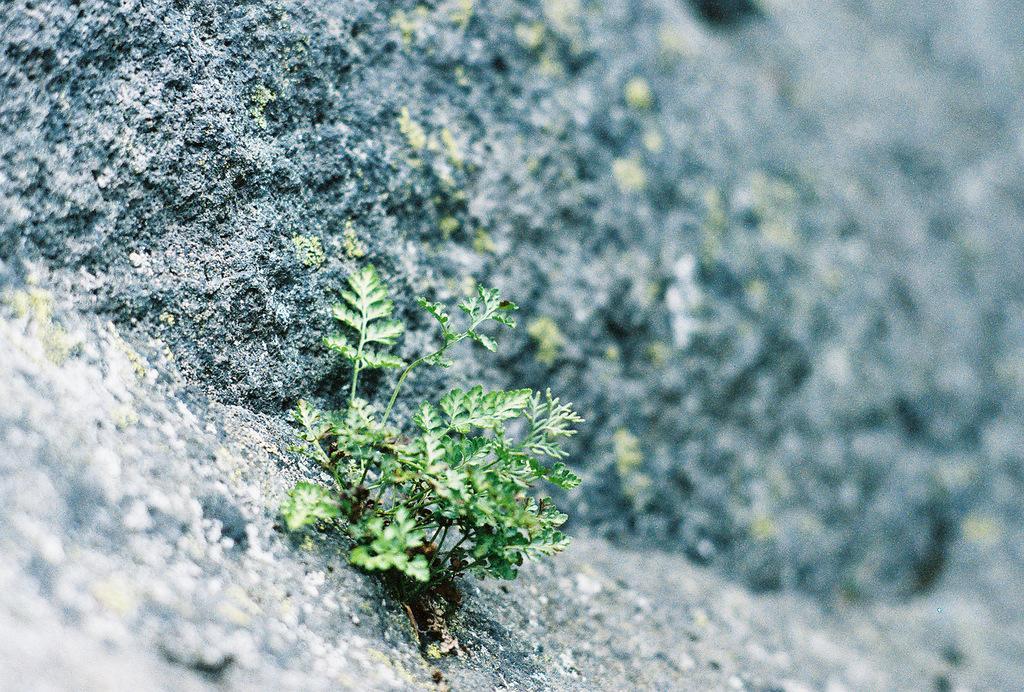In one or two sentences, can you explain what this image depicts? In this image I can see a green color plant and black color rock. 